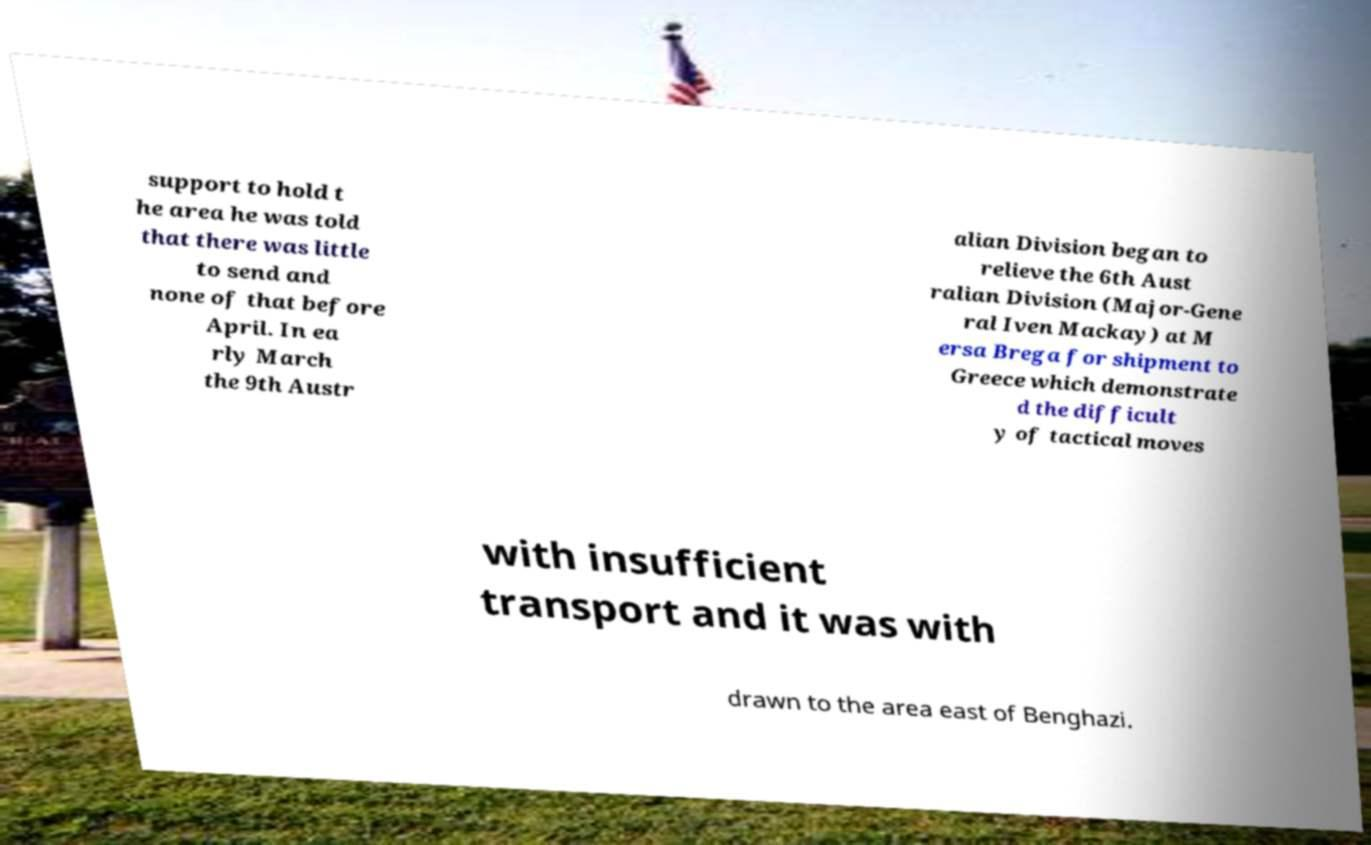Please read and relay the text visible in this image. What does it say? support to hold t he area he was told that there was little to send and none of that before April. In ea rly March the 9th Austr alian Division began to relieve the 6th Aust ralian Division (Major-Gene ral Iven Mackay) at M ersa Brega for shipment to Greece which demonstrate d the difficult y of tactical moves with insufficient transport and it was with drawn to the area east of Benghazi. 